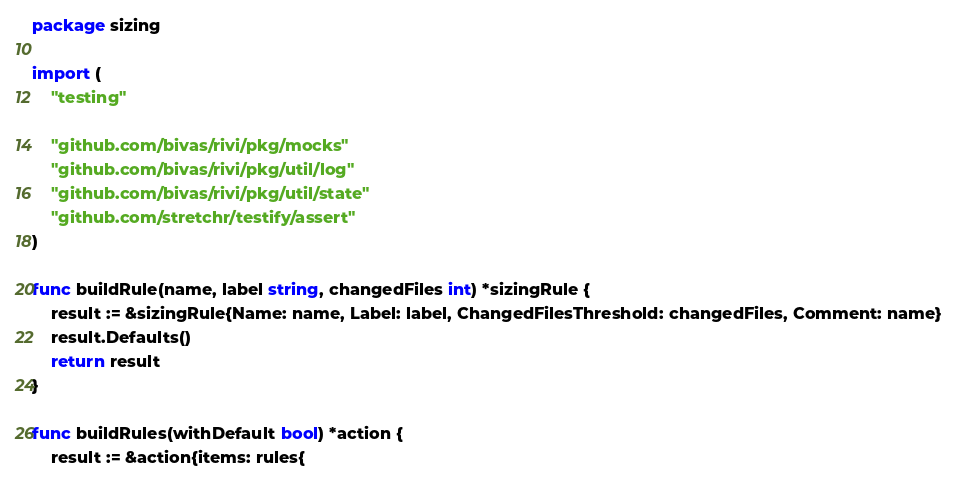<code> <loc_0><loc_0><loc_500><loc_500><_Go_>package sizing

import (
	"testing"

	"github.com/bivas/rivi/pkg/mocks"
	"github.com/bivas/rivi/pkg/util/log"
	"github.com/bivas/rivi/pkg/util/state"
	"github.com/stretchr/testify/assert"
)

func buildRule(name, label string, changedFiles int) *sizingRule {
	result := &sizingRule{Name: name, Label: label, ChangedFilesThreshold: changedFiles, Comment: name}
	result.Defaults()
	return result
}

func buildRules(withDefault bool) *action {
	result := &action{items: rules{</code> 